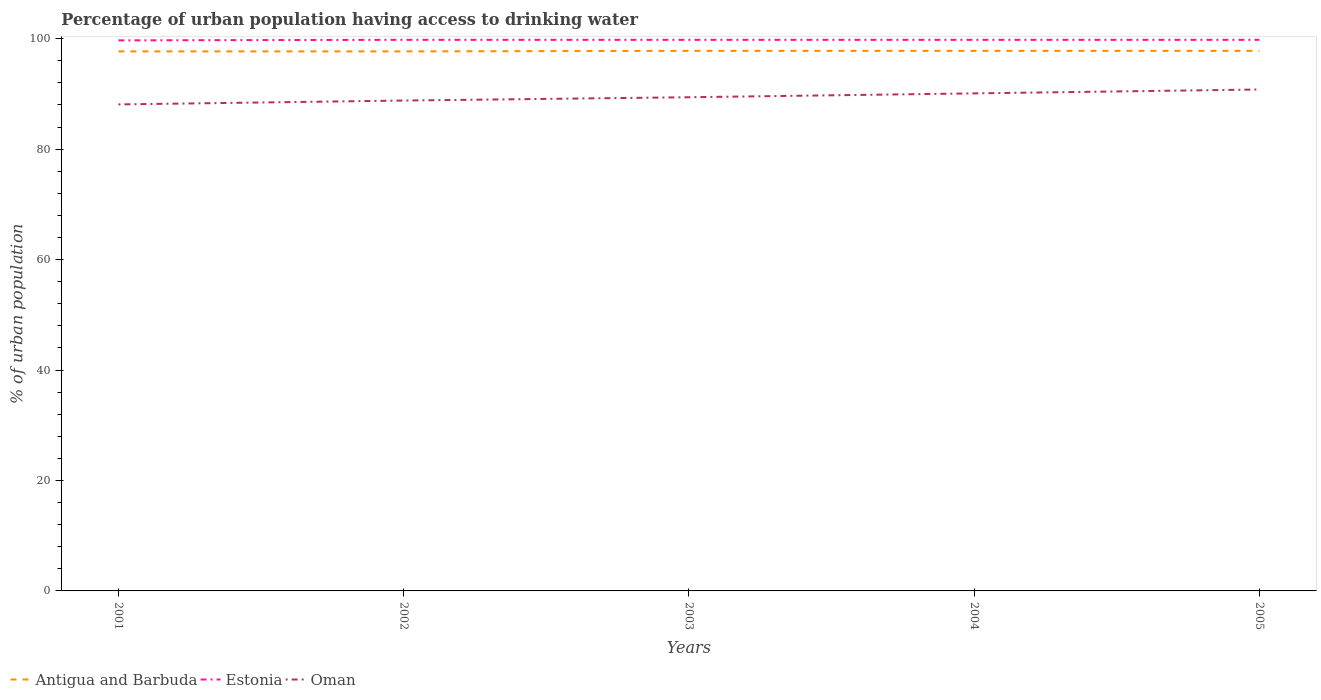Does the line corresponding to Antigua and Barbuda intersect with the line corresponding to Estonia?
Make the answer very short. No. Is the number of lines equal to the number of legend labels?
Keep it short and to the point. Yes. Across all years, what is the maximum percentage of urban population having access to drinking water in Antigua and Barbuda?
Your answer should be compact. 97.7. What is the total percentage of urban population having access to drinking water in Oman in the graph?
Offer a very short reply. -1.4. What is the difference between the highest and the second highest percentage of urban population having access to drinking water in Oman?
Your answer should be very brief. 2.7. How many years are there in the graph?
Give a very brief answer. 5. Are the values on the major ticks of Y-axis written in scientific E-notation?
Give a very brief answer. No. How many legend labels are there?
Your answer should be very brief. 3. How are the legend labels stacked?
Offer a very short reply. Horizontal. What is the title of the graph?
Your answer should be very brief. Percentage of urban population having access to drinking water. Does "Gambia, The" appear as one of the legend labels in the graph?
Offer a terse response. No. What is the label or title of the Y-axis?
Keep it short and to the point. % of urban population. What is the % of urban population in Antigua and Barbuda in 2001?
Keep it short and to the point. 97.7. What is the % of urban population in Estonia in 2001?
Your answer should be very brief. 99.7. What is the % of urban population in Oman in 2001?
Make the answer very short. 88.1. What is the % of urban population in Antigua and Barbuda in 2002?
Give a very brief answer. 97.7. What is the % of urban population of Estonia in 2002?
Offer a very short reply. 99.8. What is the % of urban population in Oman in 2002?
Keep it short and to the point. 88.8. What is the % of urban population in Antigua and Barbuda in 2003?
Provide a short and direct response. 97.8. What is the % of urban population in Estonia in 2003?
Your answer should be compact. 99.8. What is the % of urban population of Oman in 2003?
Offer a very short reply. 89.4. What is the % of urban population in Antigua and Barbuda in 2004?
Your answer should be very brief. 97.8. What is the % of urban population of Estonia in 2004?
Provide a short and direct response. 99.8. What is the % of urban population of Oman in 2004?
Offer a terse response. 90.1. What is the % of urban population of Antigua and Barbuda in 2005?
Your answer should be compact. 97.8. What is the % of urban population in Estonia in 2005?
Provide a short and direct response. 99.8. What is the % of urban population of Oman in 2005?
Offer a terse response. 90.8. Across all years, what is the maximum % of urban population in Antigua and Barbuda?
Offer a very short reply. 97.8. Across all years, what is the maximum % of urban population of Estonia?
Offer a very short reply. 99.8. Across all years, what is the maximum % of urban population of Oman?
Make the answer very short. 90.8. Across all years, what is the minimum % of urban population in Antigua and Barbuda?
Your response must be concise. 97.7. Across all years, what is the minimum % of urban population of Estonia?
Keep it short and to the point. 99.7. Across all years, what is the minimum % of urban population in Oman?
Your response must be concise. 88.1. What is the total % of urban population of Antigua and Barbuda in the graph?
Keep it short and to the point. 488.8. What is the total % of urban population of Estonia in the graph?
Keep it short and to the point. 498.9. What is the total % of urban population of Oman in the graph?
Offer a very short reply. 447.2. What is the difference between the % of urban population in Estonia in 2001 and that in 2002?
Your answer should be compact. -0.1. What is the difference between the % of urban population in Oman in 2001 and that in 2002?
Keep it short and to the point. -0.7. What is the difference between the % of urban population in Antigua and Barbuda in 2001 and that in 2004?
Ensure brevity in your answer.  -0.1. What is the difference between the % of urban population in Oman in 2002 and that in 2003?
Your answer should be compact. -0.6. What is the difference between the % of urban population in Estonia in 2002 and that in 2004?
Your answer should be compact. 0. What is the difference between the % of urban population in Oman in 2002 and that in 2004?
Your answer should be very brief. -1.3. What is the difference between the % of urban population of Estonia in 2002 and that in 2005?
Offer a terse response. 0. What is the difference between the % of urban population in Antigua and Barbuda in 2003 and that in 2004?
Your answer should be compact. 0. What is the difference between the % of urban population in Antigua and Barbuda in 2003 and that in 2005?
Provide a short and direct response. 0. What is the difference between the % of urban population in Antigua and Barbuda in 2004 and that in 2005?
Your response must be concise. 0. What is the difference between the % of urban population of Antigua and Barbuda in 2001 and the % of urban population of Oman in 2002?
Offer a terse response. 8.9. What is the difference between the % of urban population of Estonia in 2001 and the % of urban population of Oman in 2002?
Offer a terse response. 10.9. What is the difference between the % of urban population in Antigua and Barbuda in 2001 and the % of urban population in Estonia in 2003?
Your answer should be very brief. -2.1. What is the difference between the % of urban population of Antigua and Barbuda in 2001 and the % of urban population of Oman in 2004?
Make the answer very short. 7.6. What is the difference between the % of urban population in Estonia in 2002 and the % of urban population in Oman in 2003?
Provide a succinct answer. 10.4. What is the difference between the % of urban population in Antigua and Barbuda in 2002 and the % of urban population in Oman in 2004?
Keep it short and to the point. 7.6. What is the difference between the % of urban population in Antigua and Barbuda in 2003 and the % of urban population in Oman in 2004?
Keep it short and to the point. 7.7. What is the difference between the % of urban population of Estonia in 2003 and the % of urban population of Oman in 2004?
Provide a succinct answer. 9.7. What is the difference between the % of urban population of Estonia in 2003 and the % of urban population of Oman in 2005?
Provide a short and direct response. 9. What is the difference between the % of urban population of Antigua and Barbuda in 2004 and the % of urban population of Oman in 2005?
Ensure brevity in your answer.  7. What is the average % of urban population in Antigua and Barbuda per year?
Offer a very short reply. 97.76. What is the average % of urban population in Estonia per year?
Your response must be concise. 99.78. What is the average % of urban population of Oman per year?
Your answer should be very brief. 89.44. In the year 2001, what is the difference between the % of urban population of Antigua and Barbuda and % of urban population of Estonia?
Your response must be concise. -2. In the year 2002, what is the difference between the % of urban population of Antigua and Barbuda and % of urban population of Estonia?
Your response must be concise. -2.1. In the year 2002, what is the difference between the % of urban population of Antigua and Barbuda and % of urban population of Oman?
Ensure brevity in your answer.  8.9. In the year 2003, what is the difference between the % of urban population of Antigua and Barbuda and % of urban population of Estonia?
Offer a terse response. -2. In the year 2003, what is the difference between the % of urban population in Antigua and Barbuda and % of urban population in Oman?
Offer a very short reply. 8.4. In the year 2003, what is the difference between the % of urban population of Estonia and % of urban population of Oman?
Provide a short and direct response. 10.4. In the year 2004, what is the difference between the % of urban population in Antigua and Barbuda and % of urban population in Estonia?
Your response must be concise. -2. In the year 2005, what is the difference between the % of urban population of Antigua and Barbuda and % of urban population of Oman?
Keep it short and to the point. 7. What is the ratio of the % of urban population in Antigua and Barbuda in 2001 to that in 2002?
Give a very brief answer. 1. What is the ratio of the % of urban population in Estonia in 2001 to that in 2002?
Give a very brief answer. 1. What is the ratio of the % of urban population in Oman in 2001 to that in 2002?
Make the answer very short. 0.99. What is the ratio of the % of urban population of Oman in 2001 to that in 2003?
Give a very brief answer. 0.99. What is the ratio of the % of urban population of Antigua and Barbuda in 2001 to that in 2004?
Provide a short and direct response. 1. What is the ratio of the % of urban population in Oman in 2001 to that in 2004?
Your answer should be compact. 0.98. What is the ratio of the % of urban population of Estonia in 2001 to that in 2005?
Keep it short and to the point. 1. What is the ratio of the % of urban population of Oman in 2001 to that in 2005?
Offer a terse response. 0.97. What is the ratio of the % of urban population in Antigua and Barbuda in 2002 to that in 2003?
Ensure brevity in your answer.  1. What is the ratio of the % of urban population of Estonia in 2002 to that in 2003?
Your answer should be very brief. 1. What is the ratio of the % of urban population of Oman in 2002 to that in 2003?
Make the answer very short. 0.99. What is the ratio of the % of urban population in Oman in 2002 to that in 2004?
Your answer should be compact. 0.99. What is the ratio of the % of urban population of Antigua and Barbuda in 2002 to that in 2005?
Provide a short and direct response. 1. What is the ratio of the % of urban population in Antigua and Barbuda in 2003 to that in 2004?
Make the answer very short. 1. What is the ratio of the % of urban population in Oman in 2003 to that in 2004?
Give a very brief answer. 0.99. What is the ratio of the % of urban population of Estonia in 2003 to that in 2005?
Provide a succinct answer. 1. What is the ratio of the % of urban population of Oman in 2003 to that in 2005?
Your answer should be very brief. 0.98. What is the ratio of the % of urban population of Antigua and Barbuda in 2004 to that in 2005?
Your answer should be compact. 1. What is the ratio of the % of urban population in Estonia in 2004 to that in 2005?
Ensure brevity in your answer.  1. What is the ratio of the % of urban population in Oman in 2004 to that in 2005?
Your answer should be very brief. 0.99. What is the difference between the highest and the second highest % of urban population of Antigua and Barbuda?
Provide a short and direct response. 0. 